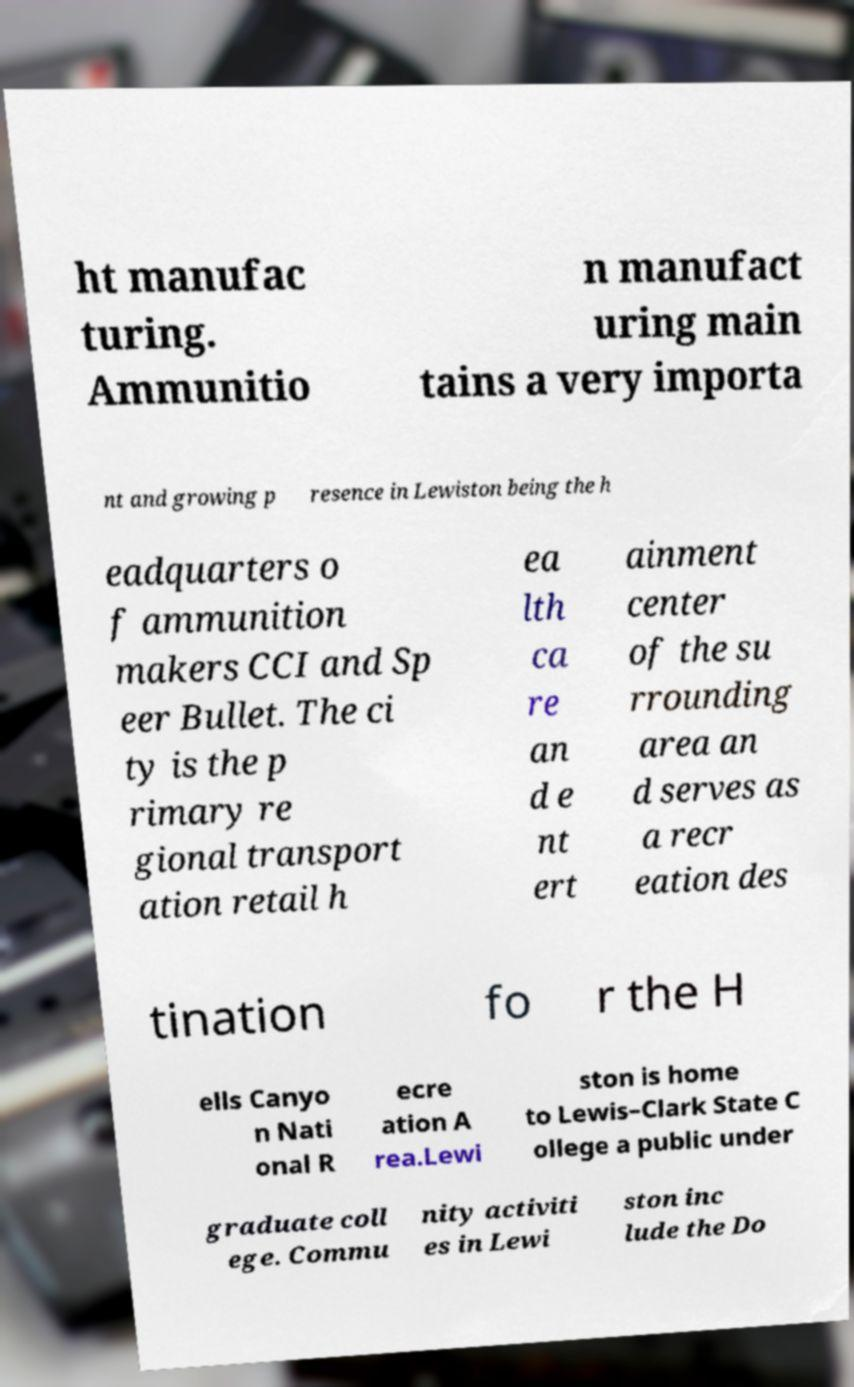There's text embedded in this image that I need extracted. Can you transcribe it verbatim? ht manufac turing. Ammunitio n manufact uring main tains a very importa nt and growing p resence in Lewiston being the h eadquarters o f ammunition makers CCI and Sp eer Bullet. The ci ty is the p rimary re gional transport ation retail h ea lth ca re an d e nt ert ainment center of the su rrounding area an d serves as a recr eation des tination fo r the H ells Canyo n Nati onal R ecre ation A rea.Lewi ston is home to Lewis–Clark State C ollege a public under graduate coll ege. Commu nity activiti es in Lewi ston inc lude the Do 